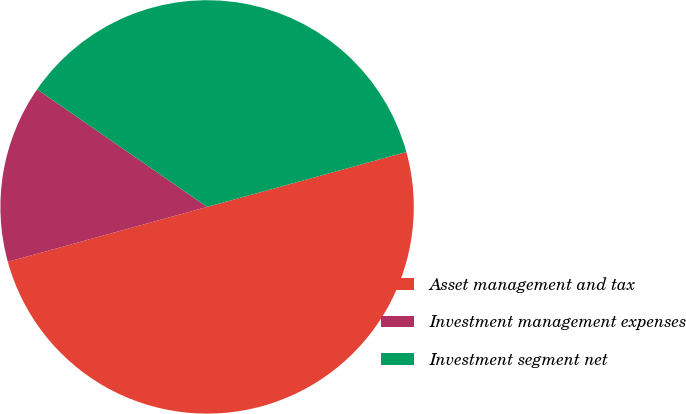Convert chart. <chart><loc_0><loc_0><loc_500><loc_500><pie_chart><fcel>Asset management and tax<fcel>Investment management expenses<fcel>Investment segment net<nl><fcel>50.0%<fcel>13.91%<fcel>36.09%<nl></chart> 